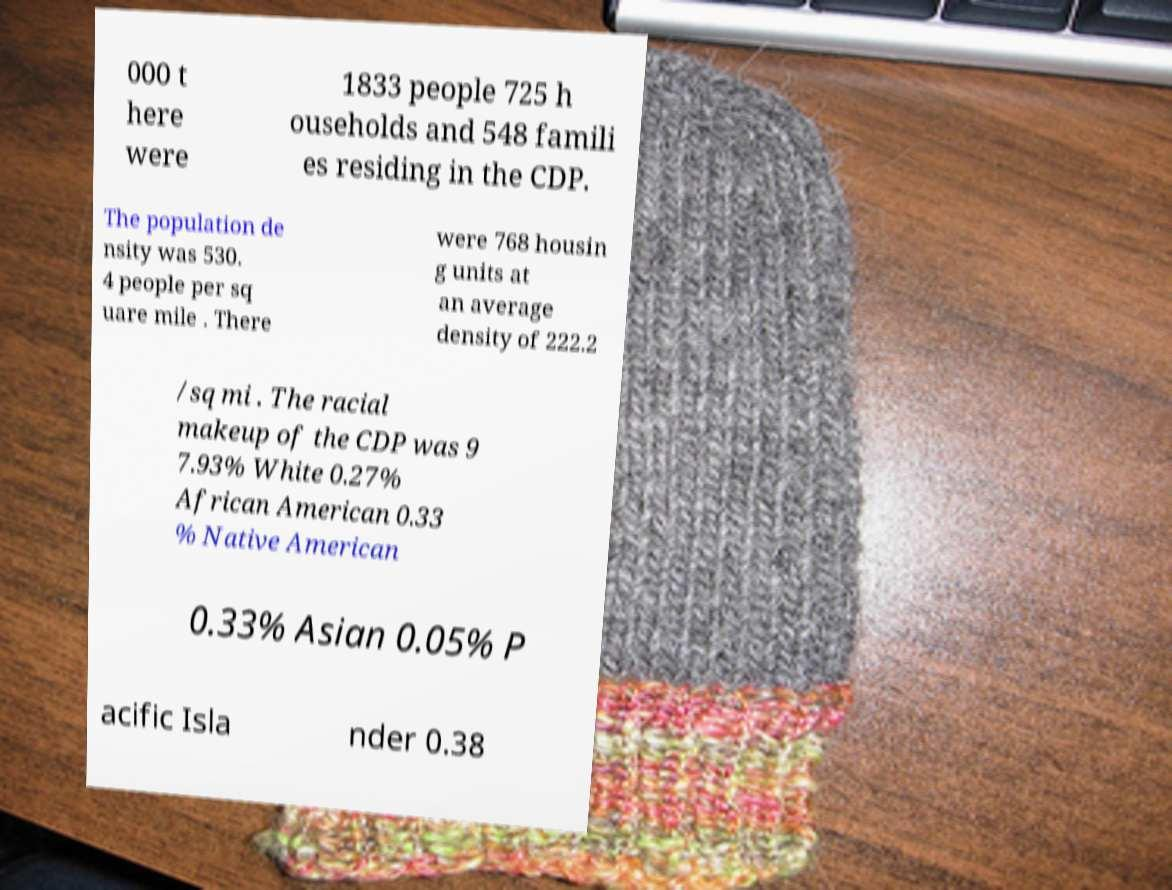Can you read and provide the text displayed in the image?This photo seems to have some interesting text. Can you extract and type it out for me? 000 t here were 1833 people 725 h ouseholds and 548 famili es residing in the CDP. The population de nsity was 530. 4 people per sq uare mile . There were 768 housin g units at an average density of 222.2 /sq mi . The racial makeup of the CDP was 9 7.93% White 0.27% African American 0.33 % Native American 0.33% Asian 0.05% P acific Isla nder 0.38 